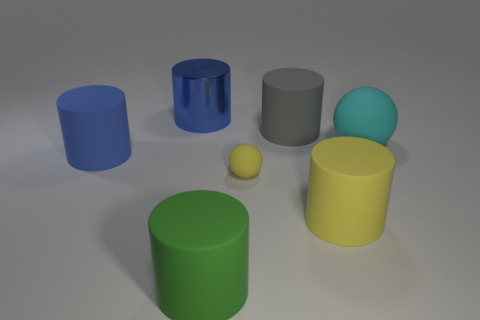There is a cyan object in front of the blue cylinder on the right side of the blue matte cylinder; what is its shape?
Make the answer very short. Sphere. How many other objects are the same shape as the large gray rubber thing?
Your answer should be compact. 4. Are there any large cylinders on the right side of the large cyan rubber ball?
Ensure brevity in your answer.  No. What color is the small object?
Your response must be concise. Yellow. Does the small matte sphere have the same color as the matte cylinder that is left of the green matte thing?
Keep it short and to the point. No. Is there a gray matte cylinder that has the same size as the cyan ball?
Provide a succinct answer. Yes. There is another object that is the same color as the small object; what size is it?
Offer a very short reply. Large. What material is the cylinder to the left of the large blue metal cylinder?
Your answer should be compact. Rubber. Are there an equal number of yellow objects that are behind the gray object and big cyan rubber spheres that are behind the big metallic object?
Ensure brevity in your answer.  Yes. Do the sphere in front of the blue matte object and the matte object left of the big green rubber object have the same size?
Your answer should be very brief. No. 